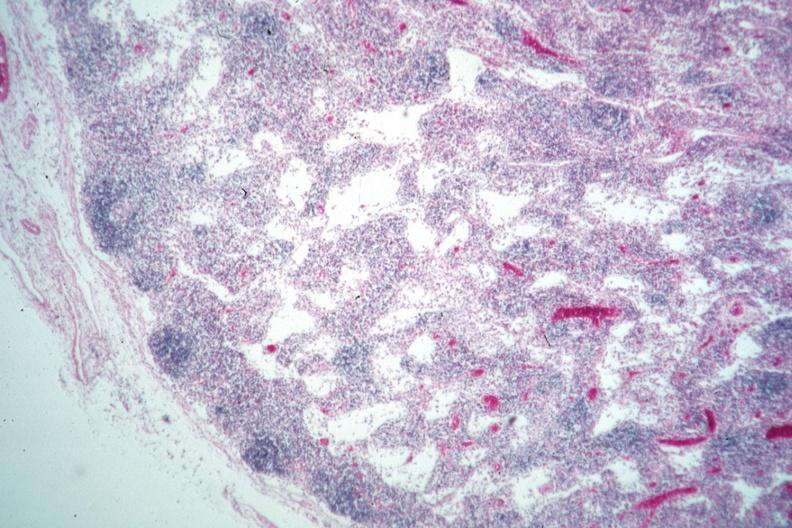s di george syndrome present?
Answer the question using a single word or phrase. Yes 